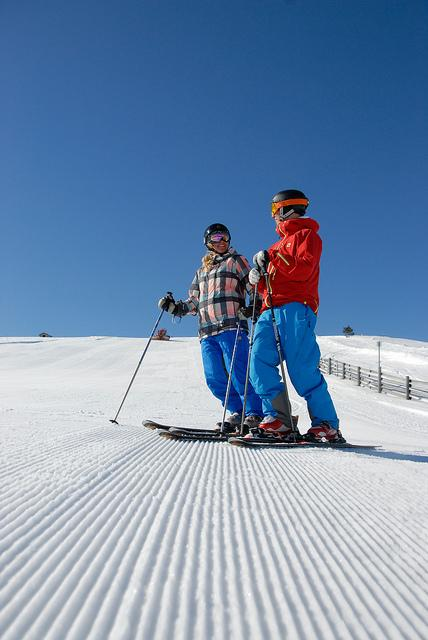Why are they so close together? friends 